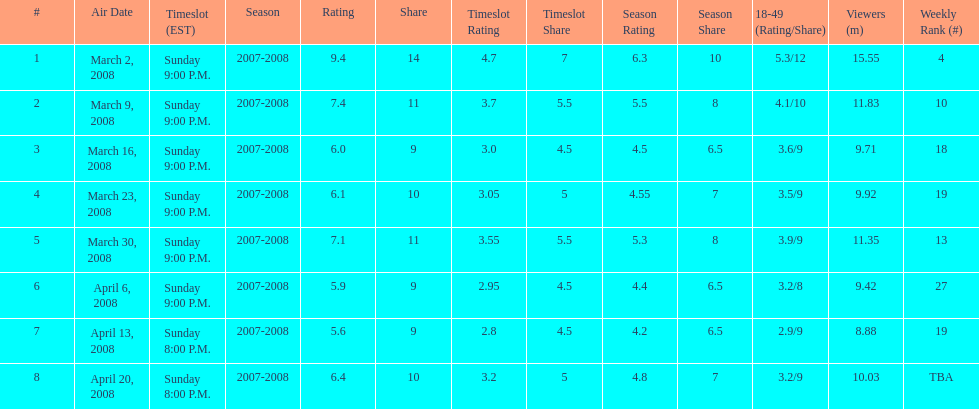How long did the program air for in days? 8. 